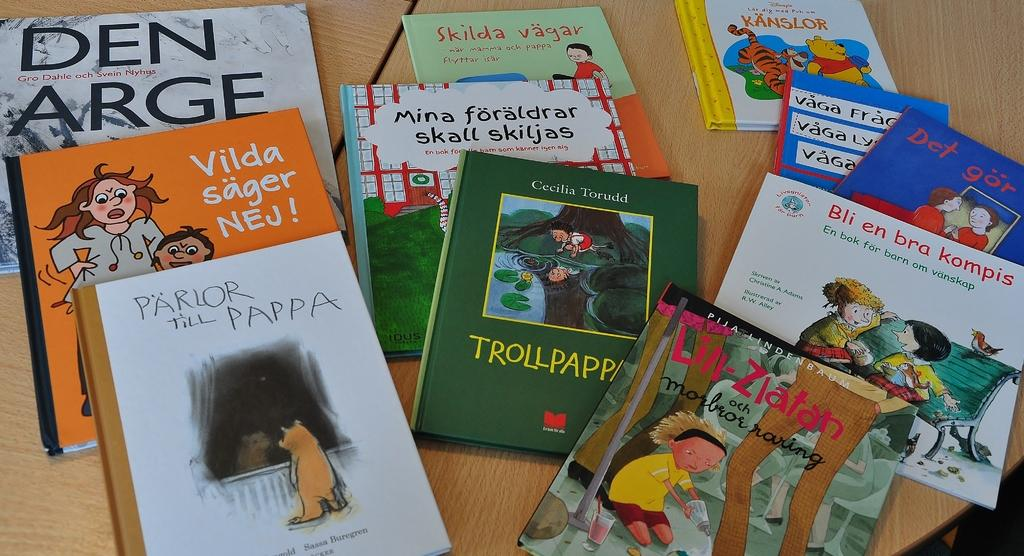<image>
Render a clear and concise summary of the photo. A number of childrens books are on a table, incluidng one by Cecilia Toruddd. 